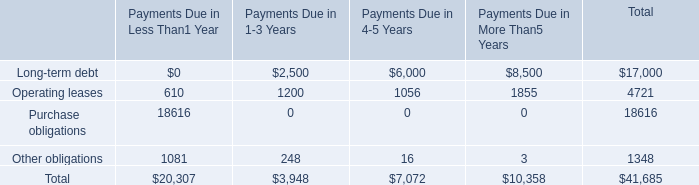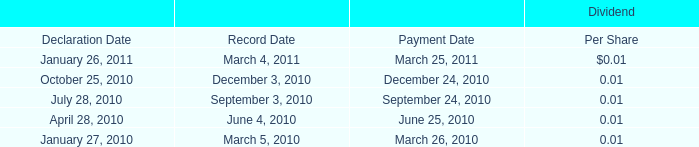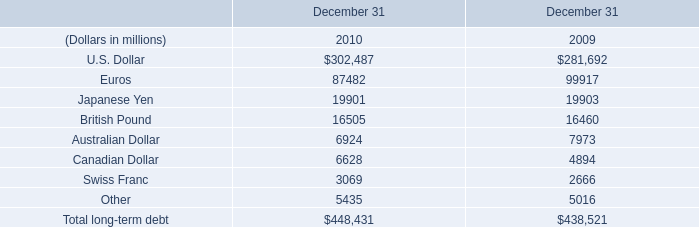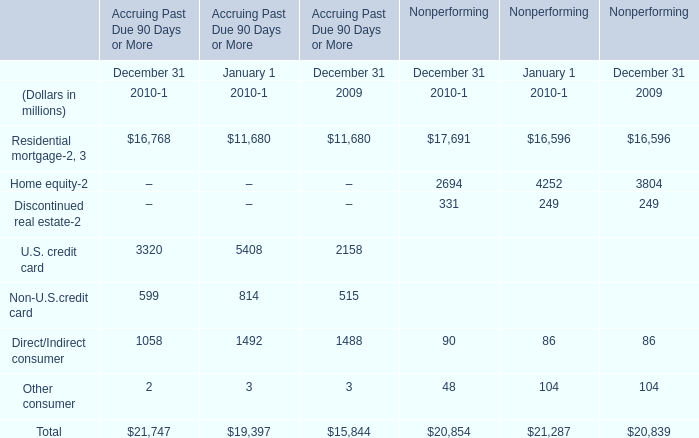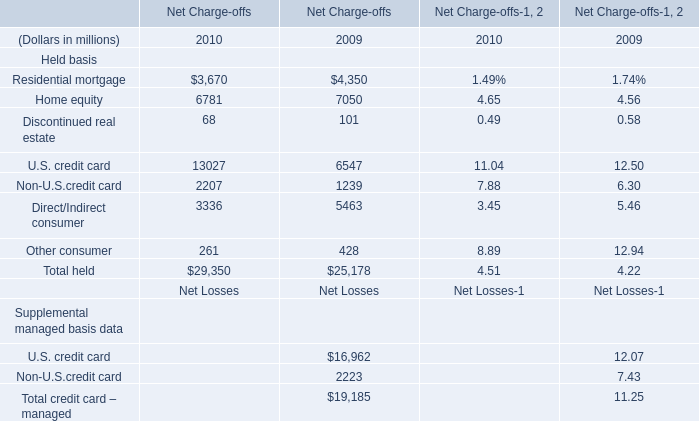What is the growing rate of Residential mortgage in Nonperforming in table 3 in the years with the least Other consumer in Nonperforming in table 3? 
Computations: ((17691 - 16596) / 16596)
Answer: 0.06598. 